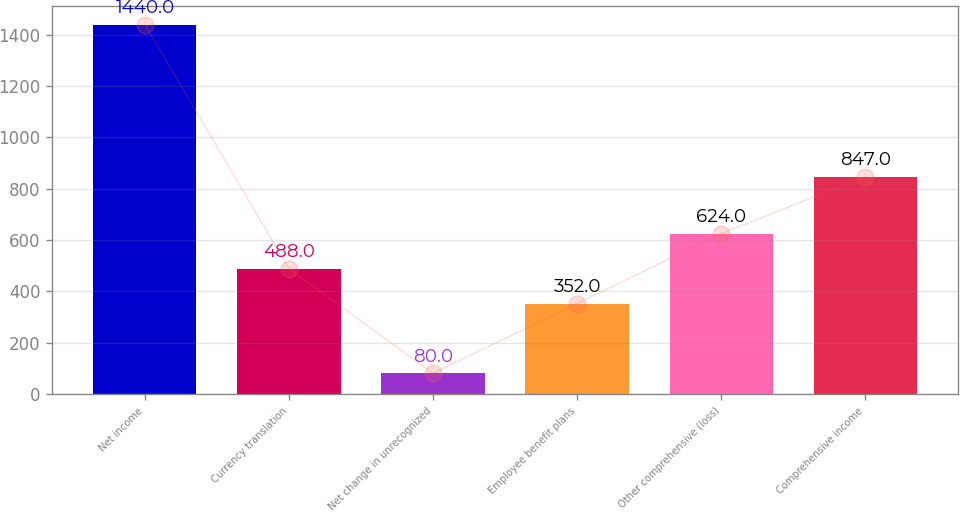<chart> <loc_0><loc_0><loc_500><loc_500><bar_chart><fcel>Net income<fcel>Currency translation<fcel>Net change in unrecognized<fcel>Employee benefit plans<fcel>Other comprehensive (loss)<fcel>Comprehensive income<nl><fcel>1440<fcel>488<fcel>80<fcel>352<fcel>624<fcel>847<nl></chart> 